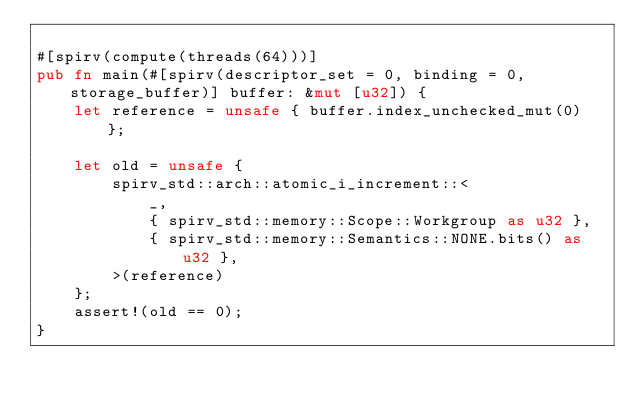<code> <loc_0><loc_0><loc_500><loc_500><_Rust_>
#[spirv(compute(threads(64)))]
pub fn main(#[spirv(descriptor_set = 0, binding = 0, storage_buffer)] buffer: &mut [u32]) {
    let reference = unsafe { buffer.index_unchecked_mut(0) };

    let old = unsafe {
        spirv_std::arch::atomic_i_increment::<
            _,
            { spirv_std::memory::Scope::Workgroup as u32 },
            { spirv_std::memory::Semantics::NONE.bits() as u32 },
        >(reference)
    };
    assert!(old == 0);
}
</code> 